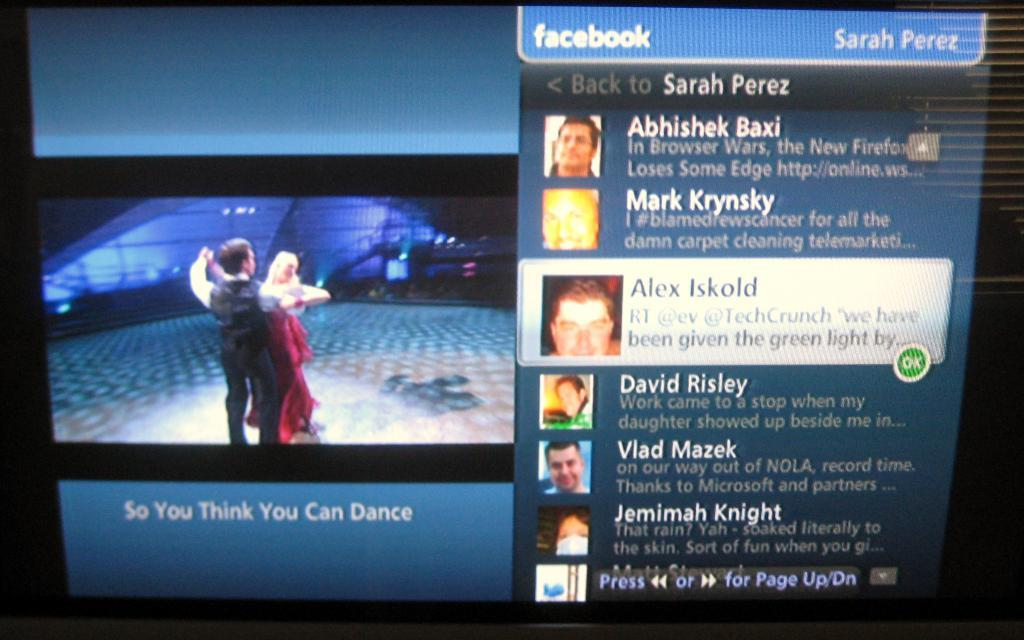<image>
Present a compact description of the photo's key features. A video of So You Think You Can Dance is played on a Facebook stream. 